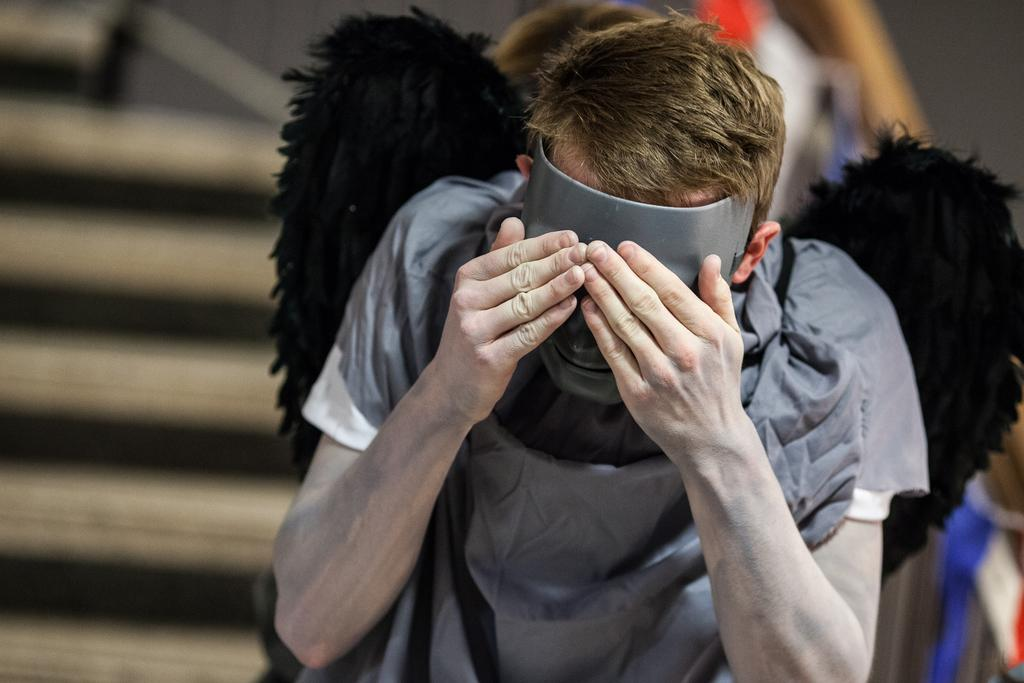What is the main subject of the image? There is a man standing in the image. Can you describe the man's attire? The man is wearing a fancy dress. What is the man wearing on his face? The man is wearing a face mask. How would you describe the background of the image? The background of the image appears blurry. Where is the pail located in the image? There is no pail present in the image. What information can be found on the calendar in the image? There is no calendar present in the image. 